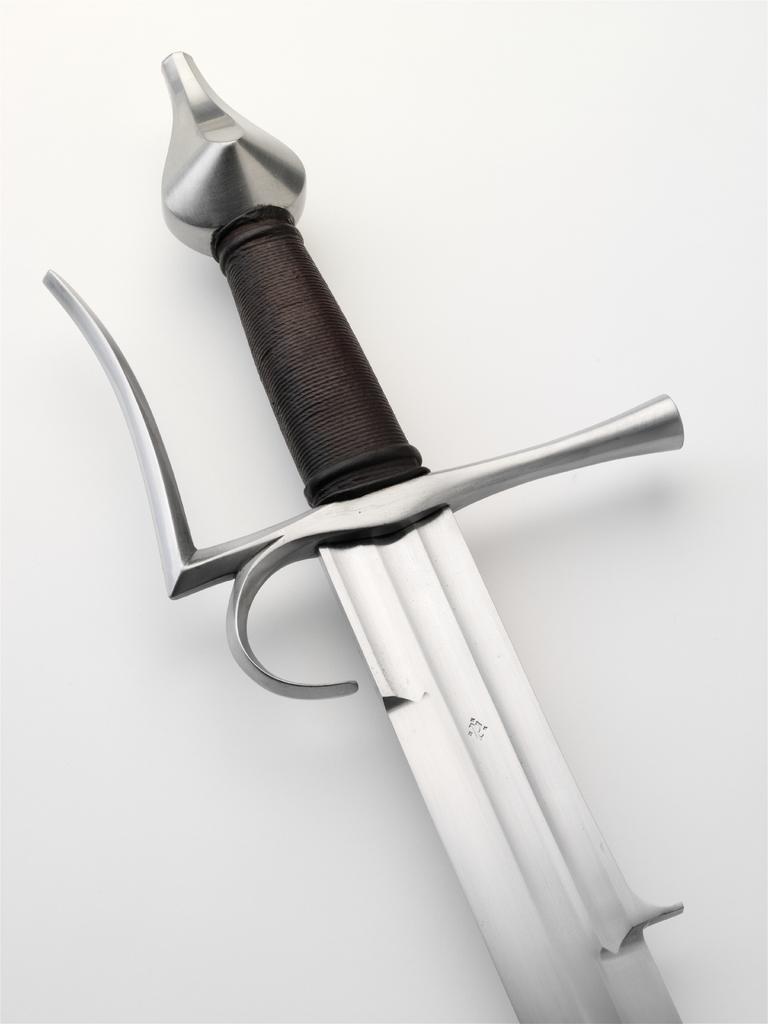Please provide a concise description of this image. The picture consists of a sword on a white surface. 